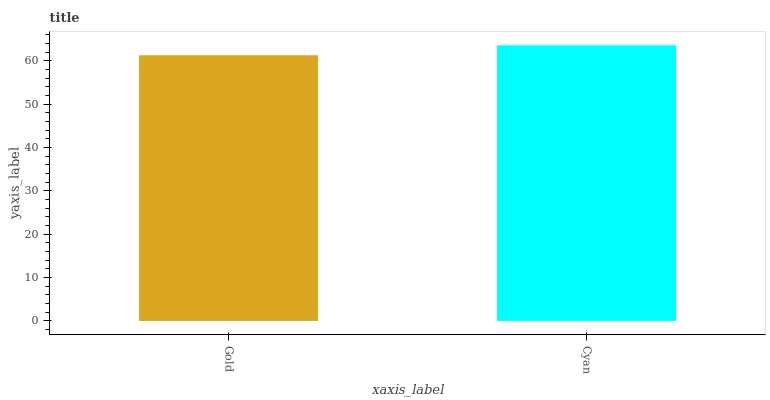Is Cyan the minimum?
Answer yes or no. No. Is Cyan greater than Gold?
Answer yes or no. Yes. Is Gold less than Cyan?
Answer yes or no. Yes. Is Gold greater than Cyan?
Answer yes or no. No. Is Cyan less than Gold?
Answer yes or no. No. Is Cyan the high median?
Answer yes or no. Yes. Is Gold the low median?
Answer yes or no. Yes. Is Gold the high median?
Answer yes or no. No. Is Cyan the low median?
Answer yes or no. No. 